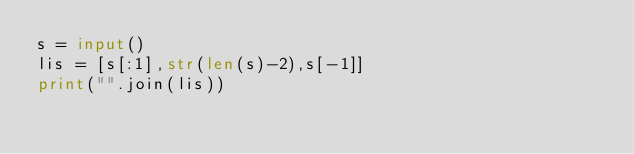<code> <loc_0><loc_0><loc_500><loc_500><_Python_>s = input()
lis = [s[:1],str(len(s)-2),s[-1]]
print("".join(lis))
</code> 